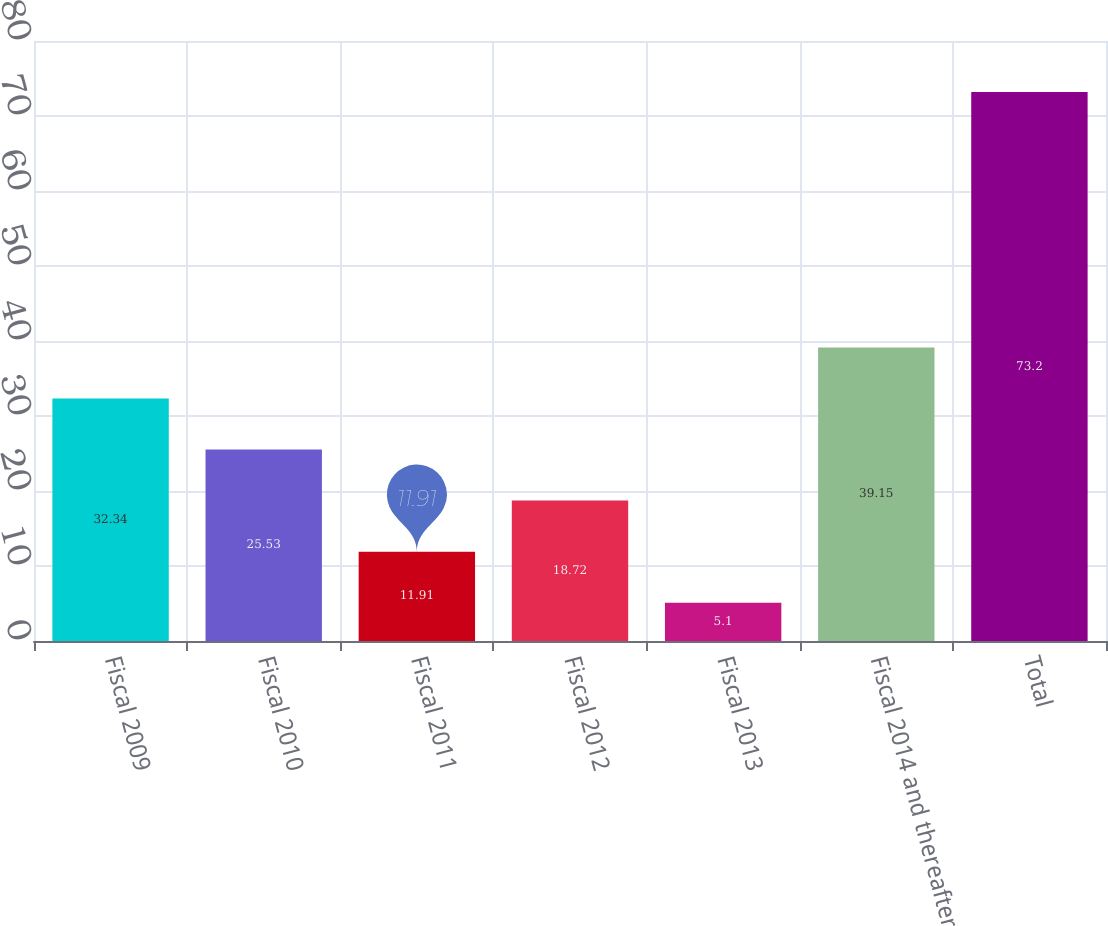Convert chart. <chart><loc_0><loc_0><loc_500><loc_500><bar_chart><fcel>Fiscal 2009<fcel>Fiscal 2010<fcel>Fiscal 2011<fcel>Fiscal 2012<fcel>Fiscal 2013<fcel>Fiscal 2014 and thereafter<fcel>Total<nl><fcel>32.34<fcel>25.53<fcel>11.91<fcel>18.72<fcel>5.1<fcel>39.15<fcel>73.2<nl></chart> 